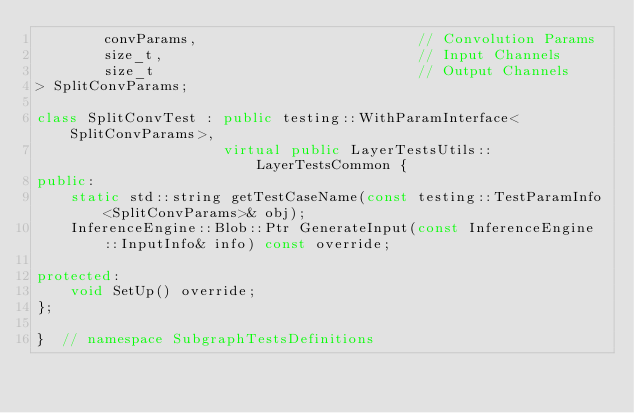Convert code to text. <code><loc_0><loc_0><loc_500><loc_500><_C++_>        convParams,                          // Convolution Params
        size_t,                              // Input Channels
        size_t                               // Output Channels
> SplitConvParams;

class SplitConvTest : public testing::WithParamInterface<SplitConvParams>,
                      virtual public LayerTestsUtils::LayerTestsCommon {
public:
    static std::string getTestCaseName(const testing::TestParamInfo<SplitConvParams>& obj);
    InferenceEngine::Blob::Ptr GenerateInput(const InferenceEngine::InputInfo& info) const override;

protected:
    void SetUp() override;
};

}  // namespace SubgraphTestsDefinitions
</code> 